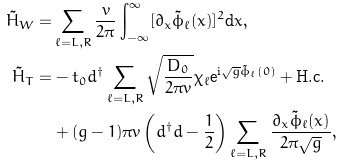<formula> <loc_0><loc_0><loc_500><loc_500>\tilde { H } _ { W } = & \sum _ { \ell = L , R } \frac { v } { 2 \pi } \int _ { - \infty } ^ { \infty } [ \partial _ { x } \tilde { \phi } _ { \ell } ( x ) ] ^ { 2 } \text {d} x , \\ \tilde { H } _ { T } = & - t _ { 0 } d ^ { \dagger } \sum _ { \ell = L , R } \sqrt { \frac { D _ { 0 } } { 2 \pi v } } \chi _ { \ell } \text {e} ^ { \text {i} \sqrt { g } \tilde { \phi } _ { \ell } ( 0 ) } + \text {H.c.} \\ & + ( g - 1 ) \pi v \left ( d ^ { \dagger } d - \frac { 1 } { 2 } \right ) \sum _ { \ell = L , R } \frac { \partial _ { x } \tilde { \phi } _ { \ell } ( x ) } { 2 \pi \sqrt { g } } ,</formula> 